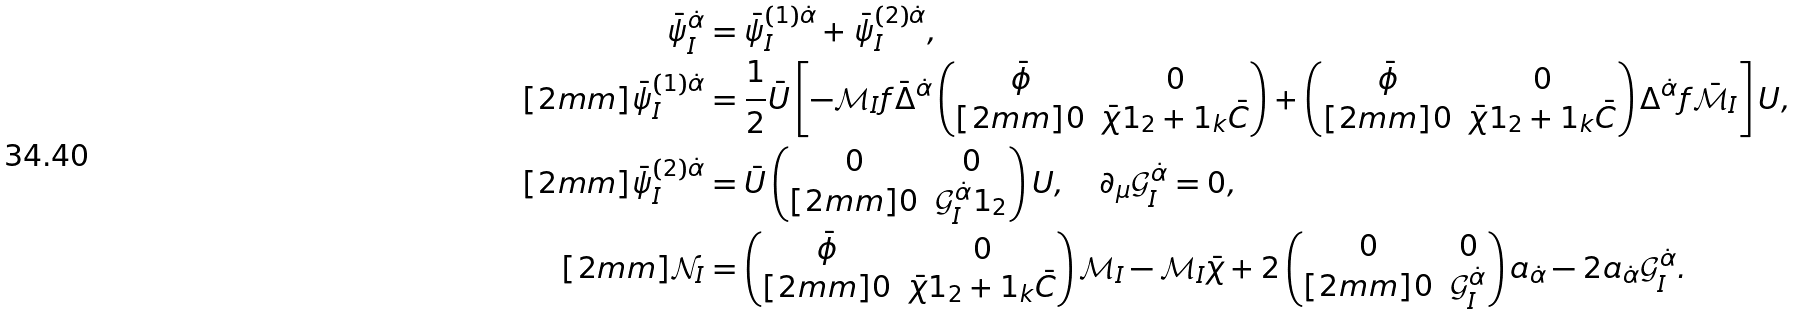Convert formula to latex. <formula><loc_0><loc_0><loc_500><loc_500>\bar { \psi } _ { I } ^ { \dot { \alpha } } & = \bar { \psi } _ { I } ^ { ( 1 ) \dot { \alpha } } + \bar { \psi } _ { I } ^ { ( 2 ) \dot { \alpha } } , \\ [ 2 m m ] \bar { \psi } _ { I } ^ { ( 1 ) \dot { \alpha } } & = \frac { 1 } { 2 } \bar { U } \left [ - \mathcal { M } _ { I } f \bar { \Delta } ^ { \dot { \alpha } } \begin{pmatrix} \bar { \phi } & 0 \\ [ 2 m m ] 0 & \bar { \chi } 1 _ { 2 } + 1 _ { k } \bar { C } \end{pmatrix} + \begin{pmatrix} \bar { \phi } & 0 \\ [ 2 m m ] 0 & \bar { \chi } 1 _ { 2 } + 1 _ { k } \bar { C } \end{pmatrix} \Delta ^ { \dot { \alpha } } f \bar { \mathcal { M } } _ { I } \right ] U , \\ [ 2 m m ] \bar { \psi } _ { I } ^ { ( 2 ) \dot { \alpha } } & = \bar { U } \begin{pmatrix} 0 & 0 \\ [ 2 m m ] 0 & \mathcal { G } _ { I } ^ { \dot { \alpha } } 1 _ { 2 } \end{pmatrix} U , \quad \partial _ { \mu } \mathcal { G } _ { I } ^ { \dot { \alpha } } = 0 , \\ [ 2 m m ] \mathcal { N } _ { I } & = \begin{pmatrix} \bar { \phi } & 0 \\ [ 2 m m ] 0 & \bar { \chi } 1 _ { 2 } + 1 _ { k } \bar { C } \end{pmatrix} \mathcal { M } _ { I } - \mathcal { M } _ { I } \bar { \chi } + 2 \begin{pmatrix} 0 & 0 \\ [ 2 m m ] 0 & \mathcal { G } _ { I } ^ { \dot { \alpha } } \end{pmatrix} a _ { \dot { \alpha } } - 2 a _ { \dot { \alpha } } \mathcal { G } _ { I } ^ { \dot { \alpha } } .</formula> 